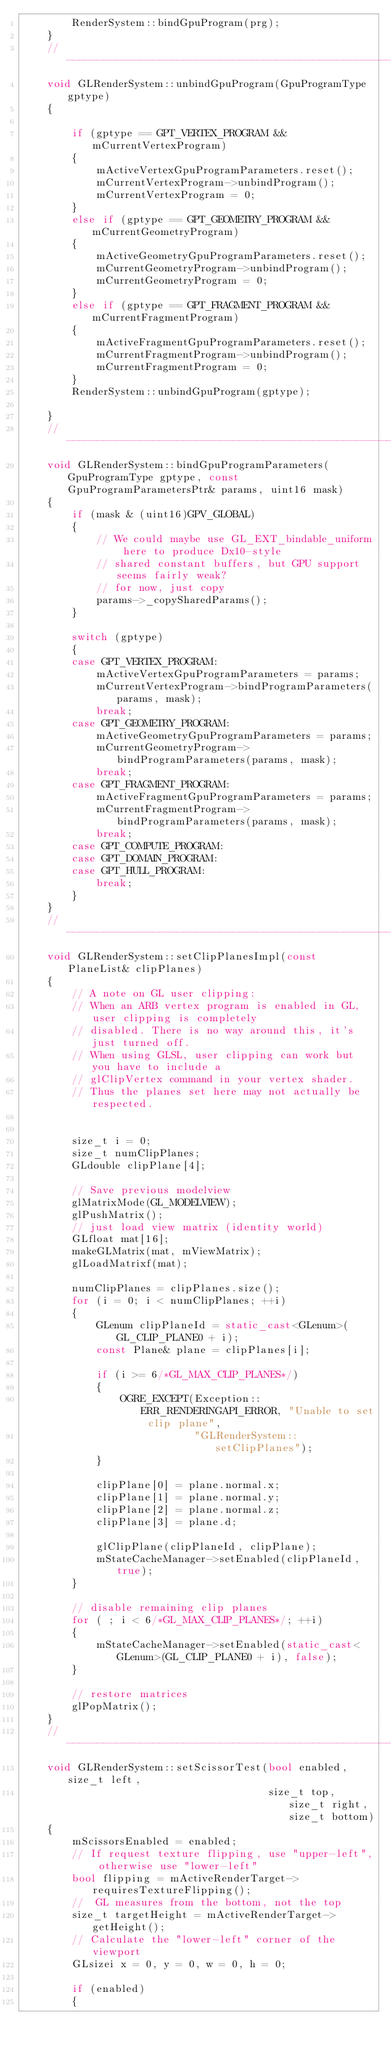Convert code to text. <code><loc_0><loc_0><loc_500><loc_500><_C++_>        RenderSystem::bindGpuProgram(prg);
    }
    //---------------------------------------------------------------------
    void GLRenderSystem::unbindGpuProgram(GpuProgramType gptype)
    {

        if (gptype == GPT_VERTEX_PROGRAM && mCurrentVertexProgram)
        {
            mActiveVertexGpuProgramParameters.reset();
            mCurrentVertexProgram->unbindProgram();
            mCurrentVertexProgram = 0;
        }
        else if (gptype == GPT_GEOMETRY_PROGRAM && mCurrentGeometryProgram)
        {
            mActiveGeometryGpuProgramParameters.reset();
            mCurrentGeometryProgram->unbindProgram();
            mCurrentGeometryProgram = 0;
        }
        else if (gptype == GPT_FRAGMENT_PROGRAM && mCurrentFragmentProgram)
        {
            mActiveFragmentGpuProgramParameters.reset();
            mCurrentFragmentProgram->unbindProgram();
            mCurrentFragmentProgram = 0;
        }
        RenderSystem::unbindGpuProgram(gptype);

    }
    //---------------------------------------------------------------------
    void GLRenderSystem::bindGpuProgramParameters(GpuProgramType gptype, const GpuProgramParametersPtr& params, uint16 mask)
    {
        if (mask & (uint16)GPV_GLOBAL)
        {
            // We could maybe use GL_EXT_bindable_uniform here to produce Dx10-style
            // shared constant buffers, but GPU support seems fairly weak?
            // for now, just copy
            params->_copySharedParams();
        }

        switch (gptype)
        {
        case GPT_VERTEX_PROGRAM:
            mActiveVertexGpuProgramParameters = params;
            mCurrentVertexProgram->bindProgramParameters(params, mask);
            break;
        case GPT_GEOMETRY_PROGRAM:
            mActiveGeometryGpuProgramParameters = params;
            mCurrentGeometryProgram->bindProgramParameters(params, mask);
            break;
        case GPT_FRAGMENT_PROGRAM:
            mActiveFragmentGpuProgramParameters = params;
            mCurrentFragmentProgram->bindProgramParameters(params, mask);
            break;
        case GPT_COMPUTE_PROGRAM:
        case GPT_DOMAIN_PROGRAM:
        case GPT_HULL_PROGRAM:
            break;
        }
    }
    //---------------------------------------------------------------------
    void GLRenderSystem::setClipPlanesImpl(const PlaneList& clipPlanes)
    {
        // A note on GL user clipping:
        // When an ARB vertex program is enabled in GL, user clipping is completely
        // disabled. There is no way around this, it's just turned off.
        // When using GLSL, user clipping can work but you have to include a
        // glClipVertex command in your vertex shader.
        // Thus the planes set here may not actually be respected.


        size_t i = 0;
        size_t numClipPlanes;
        GLdouble clipPlane[4];

        // Save previous modelview
        glMatrixMode(GL_MODELVIEW);
        glPushMatrix();
        // just load view matrix (identity world)
        GLfloat mat[16];
        makeGLMatrix(mat, mViewMatrix);
        glLoadMatrixf(mat);

        numClipPlanes = clipPlanes.size();
        for (i = 0; i < numClipPlanes; ++i)
        {
            GLenum clipPlaneId = static_cast<GLenum>(GL_CLIP_PLANE0 + i);
            const Plane& plane = clipPlanes[i];

            if (i >= 6/*GL_MAX_CLIP_PLANES*/)
            {
                OGRE_EXCEPT(Exception::ERR_RENDERINGAPI_ERROR, "Unable to set clip plane",
                            "GLRenderSystem::setClipPlanes");
            }

            clipPlane[0] = plane.normal.x;
            clipPlane[1] = plane.normal.y;
            clipPlane[2] = plane.normal.z;
            clipPlane[3] = plane.d;

            glClipPlane(clipPlaneId, clipPlane);
            mStateCacheManager->setEnabled(clipPlaneId, true);
        }

        // disable remaining clip planes
        for ( ; i < 6/*GL_MAX_CLIP_PLANES*/; ++i)
        {
            mStateCacheManager->setEnabled(static_cast<GLenum>(GL_CLIP_PLANE0 + i), false);
        }

        // restore matrices
        glPopMatrix();
    }
    //---------------------------------------------------------------------
    void GLRenderSystem::setScissorTest(bool enabled, size_t left,
                                        size_t top, size_t right, size_t bottom)
    {
        mScissorsEnabled = enabled;
        // If request texture flipping, use "upper-left", otherwise use "lower-left"
        bool flipping = mActiveRenderTarget->requiresTextureFlipping();
        //  GL measures from the bottom, not the top
        size_t targetHeight = mActiveRenderTarget->getHeight();
        // Calculate the "lower-left" corner of the viewport
        GLsizei x = 0, y = 0, w = 0, h = 0;

        if (enabled)
        {</code> 